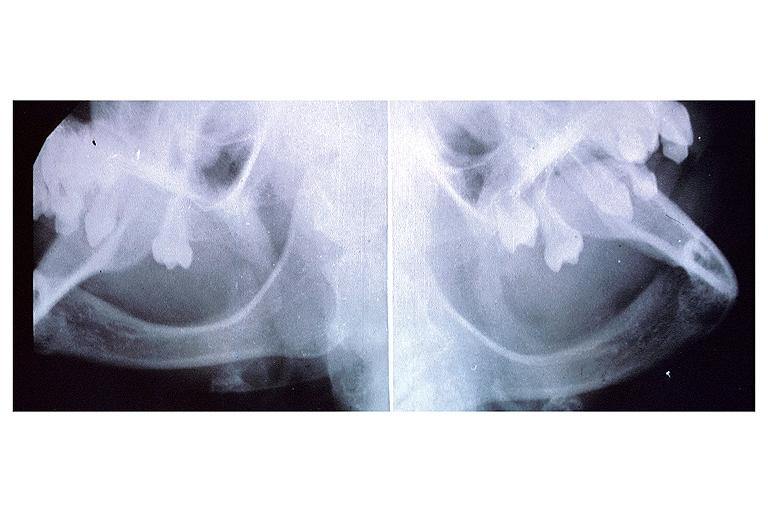where is this?
Answer the question using a single word or phrase. Oral 